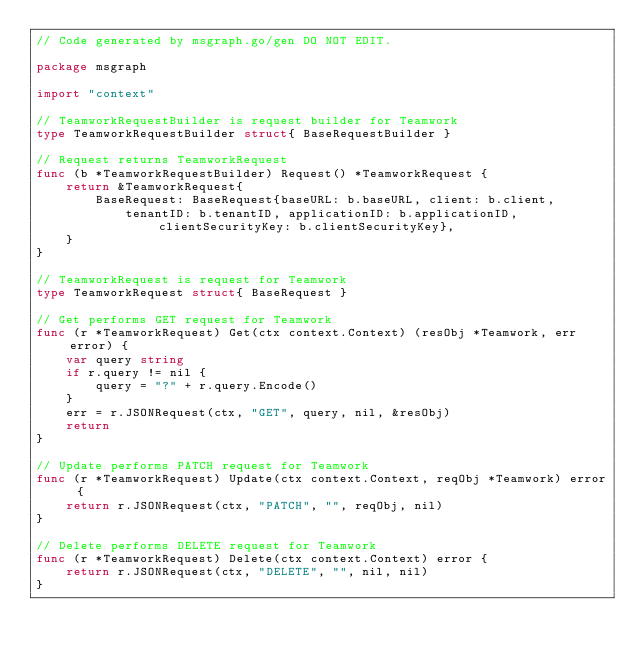Convert code to text. <code><loc_0><loc_0><loc_500><loc_500><_Go_>// Code generated by msgraph.go/gen DO NOT EDIT.

package msgraph

import "context"

// TeamworkRequestBuilder is request builder for Teamwork
type TeamworkRequestBuilder struct{ BaseRequestBuilder }

// Request returns TeamworkRequest
func (b *TeamworkRequestBuilder) Request() *TeamworkRequest {
	return &TeamworkRequest{
		BaseRequest: BaseRequest{baseURL: b.baseURL, client: b.client,
			tenantID: b.tenantID, applicationID: b.applicationID, clientSecurityKey: b.clientSecurityKey},
	}
}

// TeamworkRequest is request for Teamwork
type TeamworkRequest struct{ BaseRequest }

// Get performs GET request for Teamwork
func (r *TeamworkRequest) Get(ctx context.Context) (resObj *Teamwork, err error) {
	var query string
	if r.query != nil {
		query = "?" + r.query.Encode()
	}
	err = r.JSONRequest(ctx, "GET", query, nil, &resObj)
	return
}

// Update performs PATCH request for Teamwork
func (r *TeamworkRequest) Update(ctx context.Context, reqObj *Teamwork) error {
	return r.JSONRequest(ctx, "PATCH", "", reqObj, nil)
}

// Delete performs DELETE request for Teamwork
func (r *TeamworkRequest) Delete(ctx context.Context) error {
	return r.JSONRequest(ctx, "DELETE", "", nil, nil)
}
</code> 